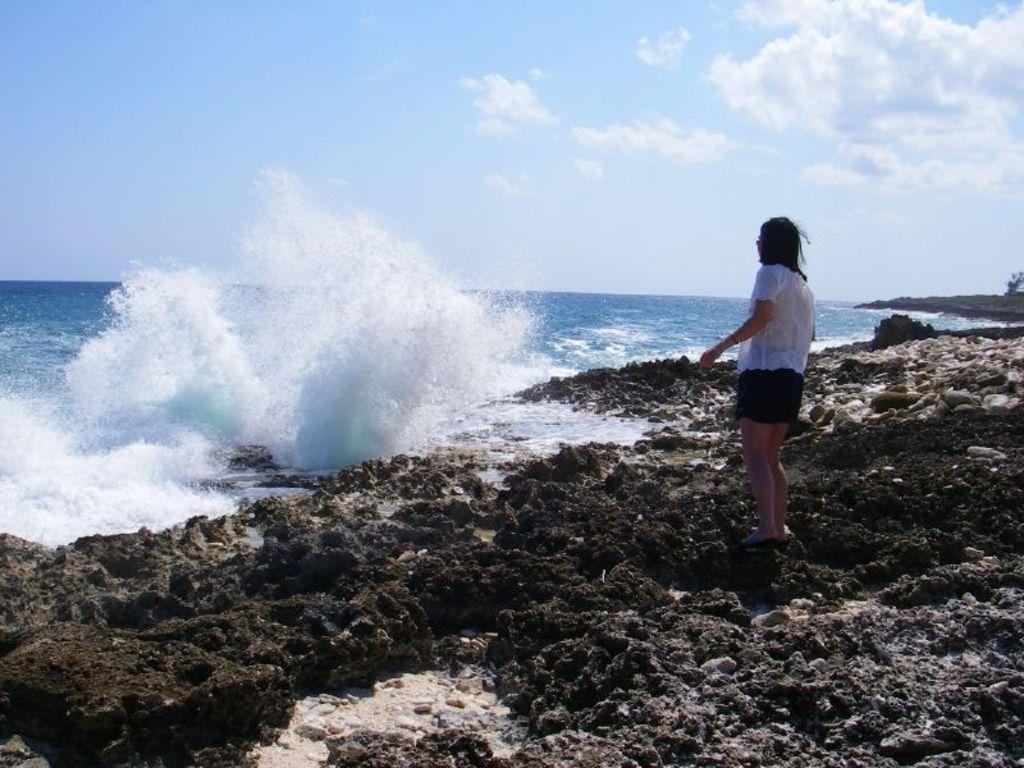What is the main subject in the foreground of the image? There is a person standing on the beach in the foreground. What can be seen in the background of the image? The background of the image includes the ocean and the sky. When was the image taken? The image was taken during the day. What is the location of the image? The location is near the ocean. How many cattle can be seen grazing on the slope in the image? There are no cattle or slopes present in the image; it features a person standing on the beach with the ocean and sky in the background. 